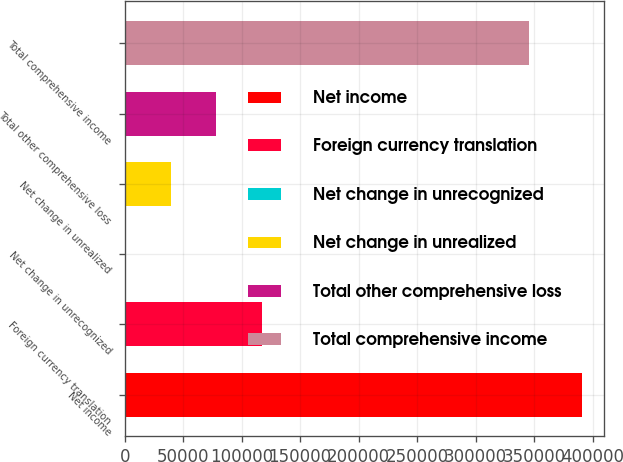Convert chart. <chart><loc_0><loc_0><loc_500><loc_500><bar_chart><fcel>Net income<fcel>Foreign currency translation<fcel>Net change in unrecognized<fcel>Net change in unrealized<fcel>Total other comprehensive loss<fcel>Total comprehensive income<nl><fcel>390486<fcel>117239<fcel>133<fcel>39168.3<fcel>78203.6<fcel>345667<nl></chart> 